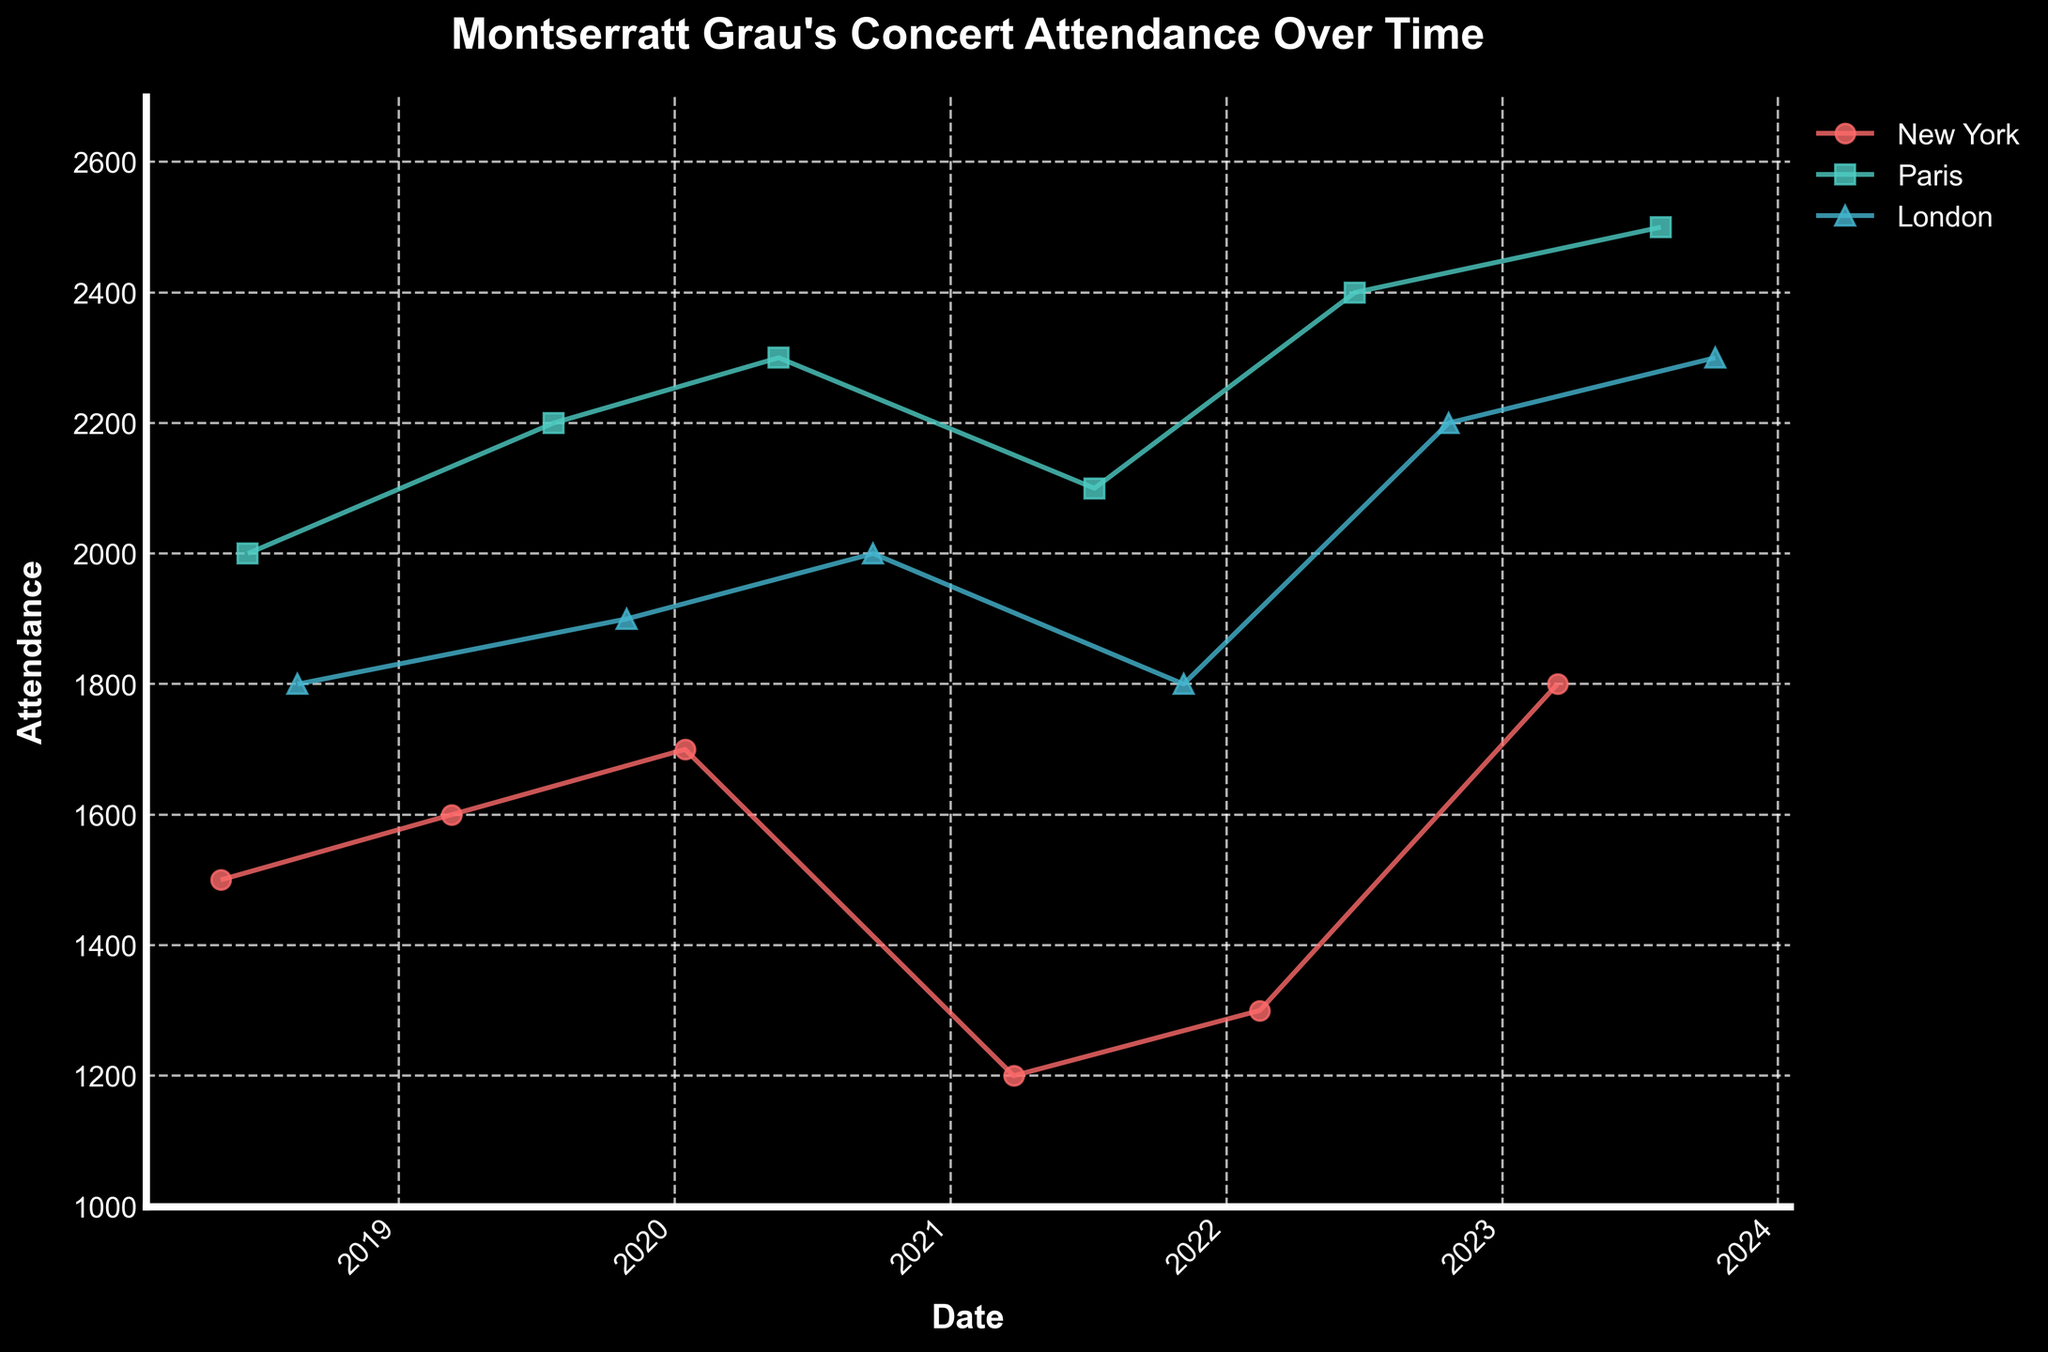What is the title of the plot? The title is displayed at the top of the plot, and it summarizes what the plot is about.
Answer: Montserratt Grau's Concert Attendance Over Time Which city had the highest attendance in the entire plot? To find the city with the highest attendance, look for the highest peak in any of the lines for New York, Paris, or London.
Answer: Paris How does concert attendance in New York change from the beginning to the end of the plot? Follow the New York line from the first data point to the last and observe the changes in attendance over time.
Answer: Increases from 1500 to 1800 Which city has the greatest increase in attendance over the course of the data? To find the greatest increase, calculate the difference between the first and last attendance values for New York, Paris, and London. Compare the differences.
Answer: Paris (increase of 500) What is the average attendance in Paris during 2020? Identify the data points for Paris in 2020 (05-18 and 09-20), sum their attendance values, and divide by the number of data points.
Answer: 2300 Which city shows a dip in attendance in 2021, and what are the values? Look for drops in the lines plotted for New York, Paris, and London in 2021, and note down the attendance values.
Answer: New York (1200) Compare the attendance for London in 2018 and 2023. Which year was higher and by how much? Look at the attendance values for London in 2018 and 2023 and calculate the difference.
Answer: 2023 by 500 Which city had the most consistent attendance throughout the years? Determine consistency by examining which city's attendance values show the least fluctuation over time.
Answer: London How many cities show increasing attendance trajectory from 2022 to 2023? Check the attendance values from 2022 to 2023 for New York, Paris, and London to see if they trend upward.
Answer: All three cities What is the total concert attendance in New York over all the years? Sum up all the attendance values for New York from 2018 to 2023.
Answer: 9200 